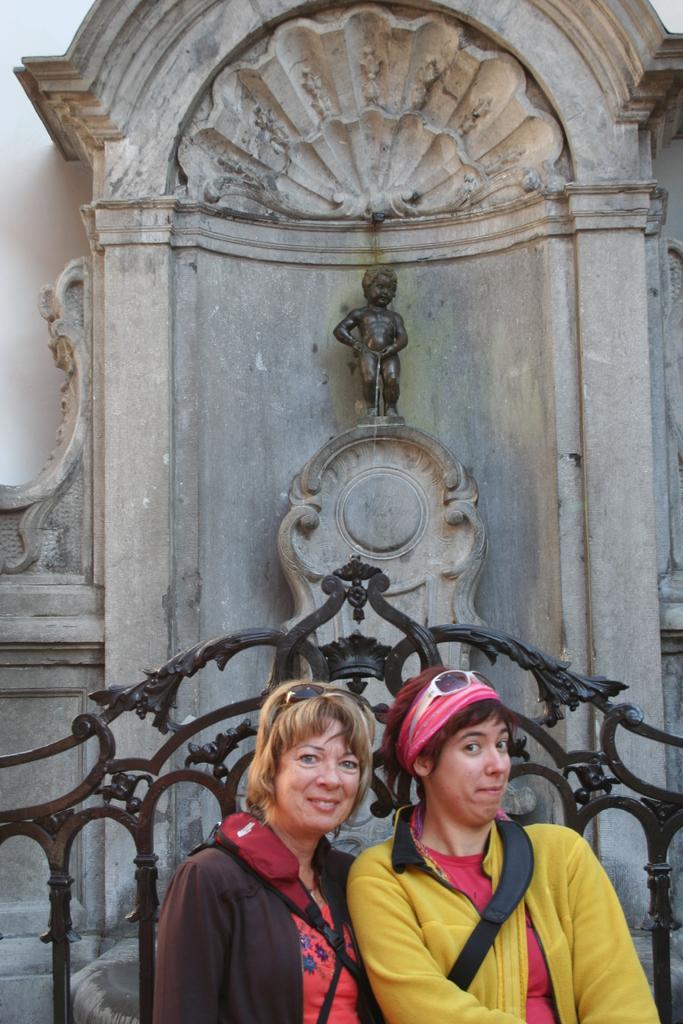How would you summarize this image in a sentence or two? In this image we can see two women wearing sweaters, glasses and backpacks are standing near the fence and smiling. In the background, we can see the child statue and the wall. 